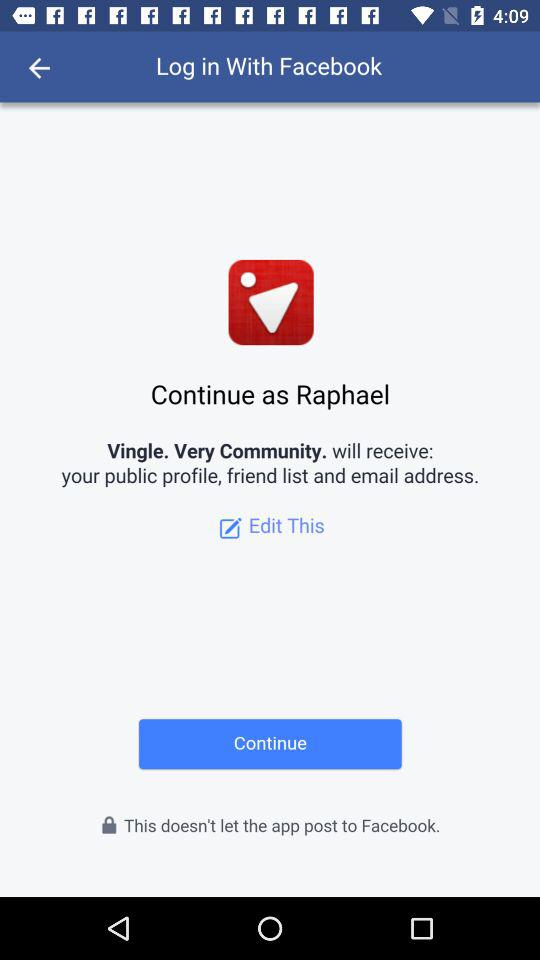What is the user name? The user name is Raphael. 